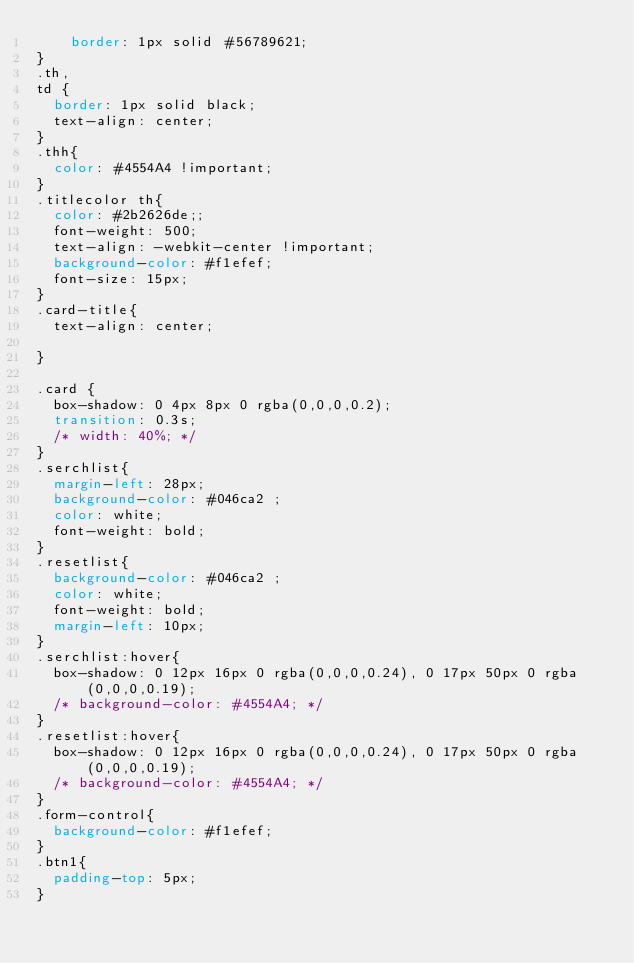Convert code to text. <code><loc_0><loc_0><loc_500><loc_500><_CSS_>    border: 1px solid #56789621;
} 
.th,
td {
  border: 1px solid black;
  text-align: center;
}
.thh{
  color: #4554A4 !important;
}
.titlecolor th{
  color: #2b2626de;;
  font-weight: 500;
  text-align: -webkit-center !important;
  background-color: #f1efef;
  font-size: 15px;
}
.card-title{
  text-align: center;

}

.card {
  box-shadow: 0 4px 8px 0 rgba(0,0,0,0.2);
  transition: 0.3s;
  /* width: 40%; */
}
.serchlist{
  margin-left: 28px;
  background-color: #046ca2 ;
  color: white;
  font-weight: bold;
}
.resetlist{
  background-color: #046ca2 ;
  color: white;
  font-weight: bold;
  margin-left: 10px;
}
.serchlist:hover{
  box-shadow: 0 12px 16px 0 rgba(0,0,0,0.24), 0 17px 50px 0 rgba(0,0,0,0.19);
  /* background-color: #4554A4; */
}
.resetlist:hover{
  box-shadow: 0 12px 16px 0 rgba(0,0,0,0.24), 0 17px 50px 0 rgba(0,0,0,0.19);
  /* background-color: #4554A4; */
}
.form-control{
  background-color: #f1efef;
}
.btn1{
  padding-top: 5px;
}</code> 